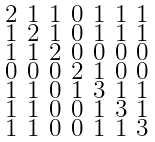<formula> <loc_0><loc_0><loc_500><loc_500>\begin{smallmatrix} 2 & 1 & 1 & 0 & 1 & 1 & 1 \\ 1 & 2 & 1 & 0 & 1 & 1 & 1 \\ 1 & 1 & 2 & 0 & 0 & 0 & 0 \\ 0 & 0 & 0 & 2 & 1 & 0 & 0 \\ 1 & 1 & 0 & 1 & 3 & 1 & 1 \\ 1 & 1 & 0 & 0 & 1 & 3 & 1 \\ 1 & 1 & 0 & 0 & 1 & 1 & 3 \end{smallmatrix}</formula> 